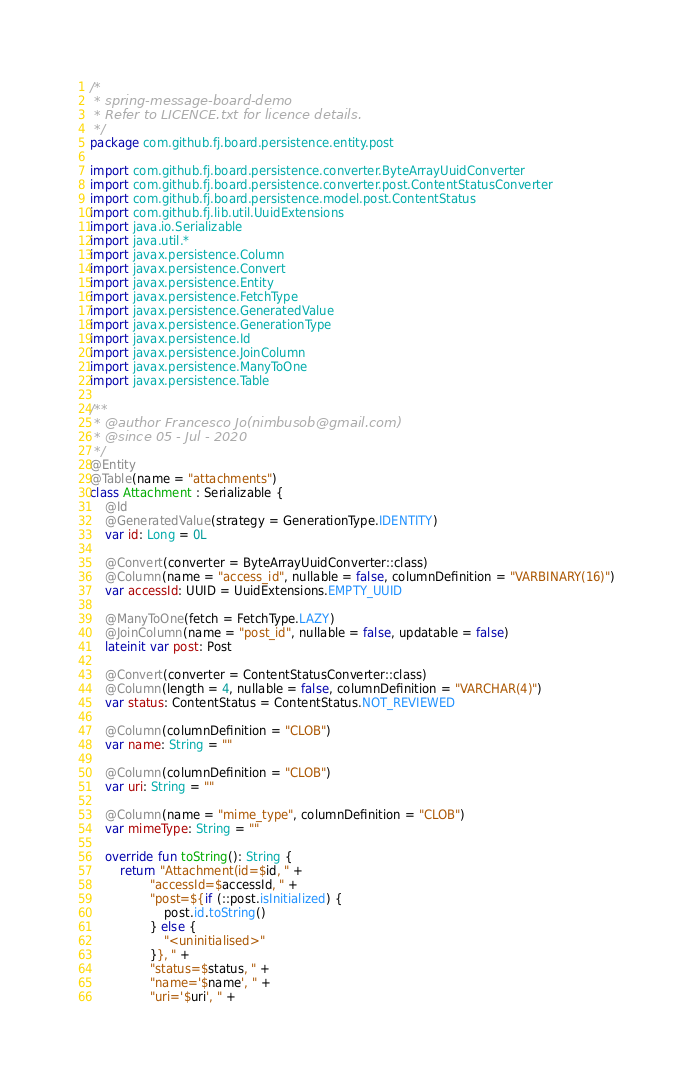Convert code to text. <code><loc_0><loc_0><loc_500><loc_500><_Kotlin_>/*
 * spring-message-board-demo
 * Refer to LICENCE.txt for licence details.
 */
package com.github.fj.board.persistence.entity.post

import com.github.fj.board.persistence.converter.ByteArrayUuidConverter
import com.github.fj.board.persistence.converter.post.ContentStatusConverter
import com.github.fj.board.persistence.model.post.ContentStatus
import com.github.fj.lib.util.UuidExtensions
import java.io.Serializable
import java.util.*
import javax.persistence.Column
import javax.persistence.Convert
import javax.persistence.Entity
import javax.persistence.FetchType
import javax.persistence.GeneratedValue
import javax.persistence.GenerationType
import javax.persistence.Id
import javax.persistence.JoinColumn
import javax.persistence.ManyToOne
import javax.persistence.Table

/**
 * @author Francesco Jo(nimbusob@gmail.com)
 * @since 05 - Jul - 2020
 */
@Entity
@Table(name = "attachments")
class Attachment : Serializable {
    @Id
    @GeneratedValue(strategy = GenerationType.IDENTITY)
    var id: Long = 0L

    @Convert(converter = ByteArrayUuidConverter::class)
    @Column(name = "access_id", nullable = false, columnDefinition = "VARBINARY(16)")
    var accessId: UUID = UuidExtensions.EMPTY_UUID

    @ManyToOne(fetch = FetchType.LAZY)
    @JoinColumn(name = "post_id", nullable = false, updatable = false)
    lateinit var post: Post

    @Convert(converter = ContentStatusConverter::class)
    @Column(length = 4, nullable = false, columnDefinition = "VARCHAR(4)")
    var status: ContentStatus = ContentStatus.NOT_REVIEWED

    @Column(columnDefinition = "CLOB")
    var name: String = ""

    @Column(columnDefinition = "CLOB")
    var uri: String = ""

    @Column(name = "mime_type", columnDefinition = "CLOB")
    var mimeType: String = ""

    override fun toString(): String {
        return "Attachment(id=$id, " +
                "accessId=$accessId, " +
                "post=${if (::post.isInitialized) {
                    post.id.toString()
                } else {
                    "<uninitialised>"
                }}, " +
                "status=$status, " +
                "name='$name', " +
                "uri='$uri', " +</code> 